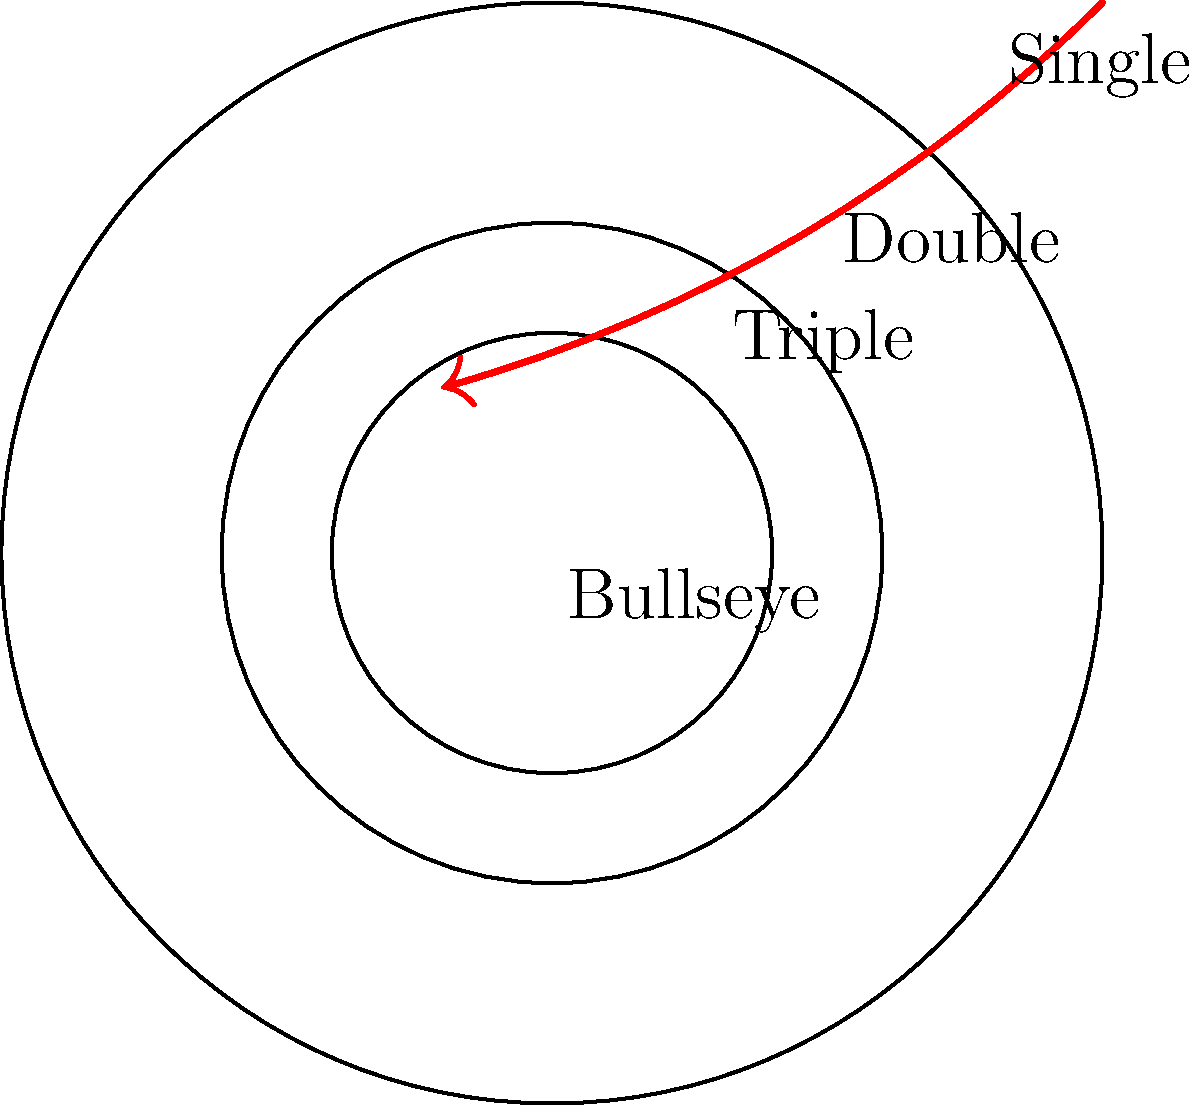In a machine learning model designed to predict dart scoring zones from trajectory images, which feature extraction technique would be most effective for capturing the curve of the dart's path, similar to Yukie Sakaguchi's throwing style? To answer this question, let's consider the following steps:

1. Analyze the dart trajectory: The image shows a curved path, which is characteristic of Yukie Sakaguchi's throwing style.

2. Understand feature extraction: We need a technique that can capture the curvature and direction of the trajectory.

3. Consider options:
   a) Convolutional Neural Networks (CNNs): Good for image recognition but may not capture the specific curve features.
   b) Histogram of Oriented Gradients (HOG): Better for object detection, not ideal for curve analysis.
   c) Hough Transform: Useful for detecting lines and circles, but not complex curves.
   d) Fourier Descriptors: Excellent for describing shape contours and curves.

4. Evaluate the best option: Fourier Descriptors can effectively capture the frequency components of the curve, which directly relates to its shape and complexity.

5. Relate to Sakaguchi's style: Fourier Descriptors can accurately represent the unique curvature of Sakaguchi's throwing style, allowing the model to learn and predict based on these distinctive features.
Answer: Fourier Descriptors 